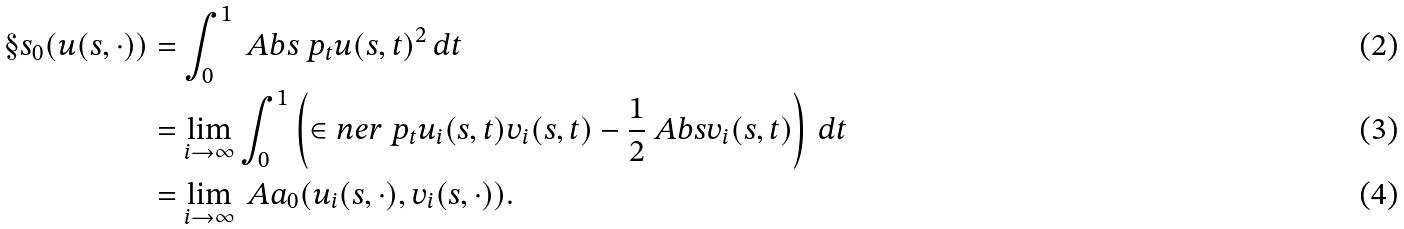<formula> <loc_0><loc_0><loc_500><loc_500>\S s _ { 0 } ( u ( s , \cdot ) ) & = \int _ { 0 } ^ { 1 } \ A b s { \ p _ { t } u ( s , t ) } ^ { 2 } \, d t \\ & = \lim _ { i \to \infty } \int _ { 0 } ^ { 1 } \left ( \in n e r { \ p _ { t } u _ { i } ( s , t ) } { v _ { i } ( s , t ) } - \frac { 1 } { 2 } \ A b s { v _ { i } ( s , t ) } \right ) \, d t \\ & = \lim _ { i \to \infty } \ A a _ { 0 } ( u _ { i } ( s , \cdot ) , v _ { i } ( s , \cdot ) ) .</formula> 